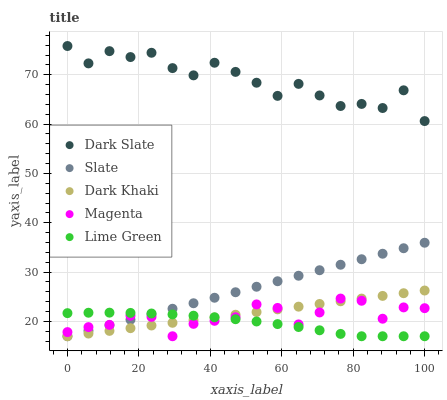Does Lime Green have the minimum area under the curve?
Answer yes or no. Yes. Does Dark Slate have the maximum area under the curve?
Answer yes or no. Yes. Does Slate have the minimum area under the curve?
Answer yes or no. No. Does Slate have the maximum area under the curve?
Answer yes or no. No. Is Dark Khaki the smoothest?
Answer yes or no. Yes. Is Dark Slate the roughest?
Answer yes or no. Yes. Is Slate the smoothest?
Answer yes or no. No. Is Slate the roughest?
Answer yes or no. No. Does Dark Khaki have the lowest value?
Answer yes or no. Yes. Does Dark Slate have the lowest value?
Answer yes or no. No. Does Dark Slate have the highest value?
Answer yes or no. Yes. Does Slate have the highest value?
Answer yes or no. No. Is Dark Khaki less than Dark Slate?
Answer yes or no. Yes. Is Dark Slate greater than Slate?
Answer yes or no. Yes. Does Lime Green intersect Slate?
Answer yes or no. Yes. Is Lime Green less than Slate?
Answer yes or no. No. Is Lime Green greater than Slate?
Answer yes or no. No. Does Dark Khaki intersect Dark Slate?
Answer yes or no. No. 